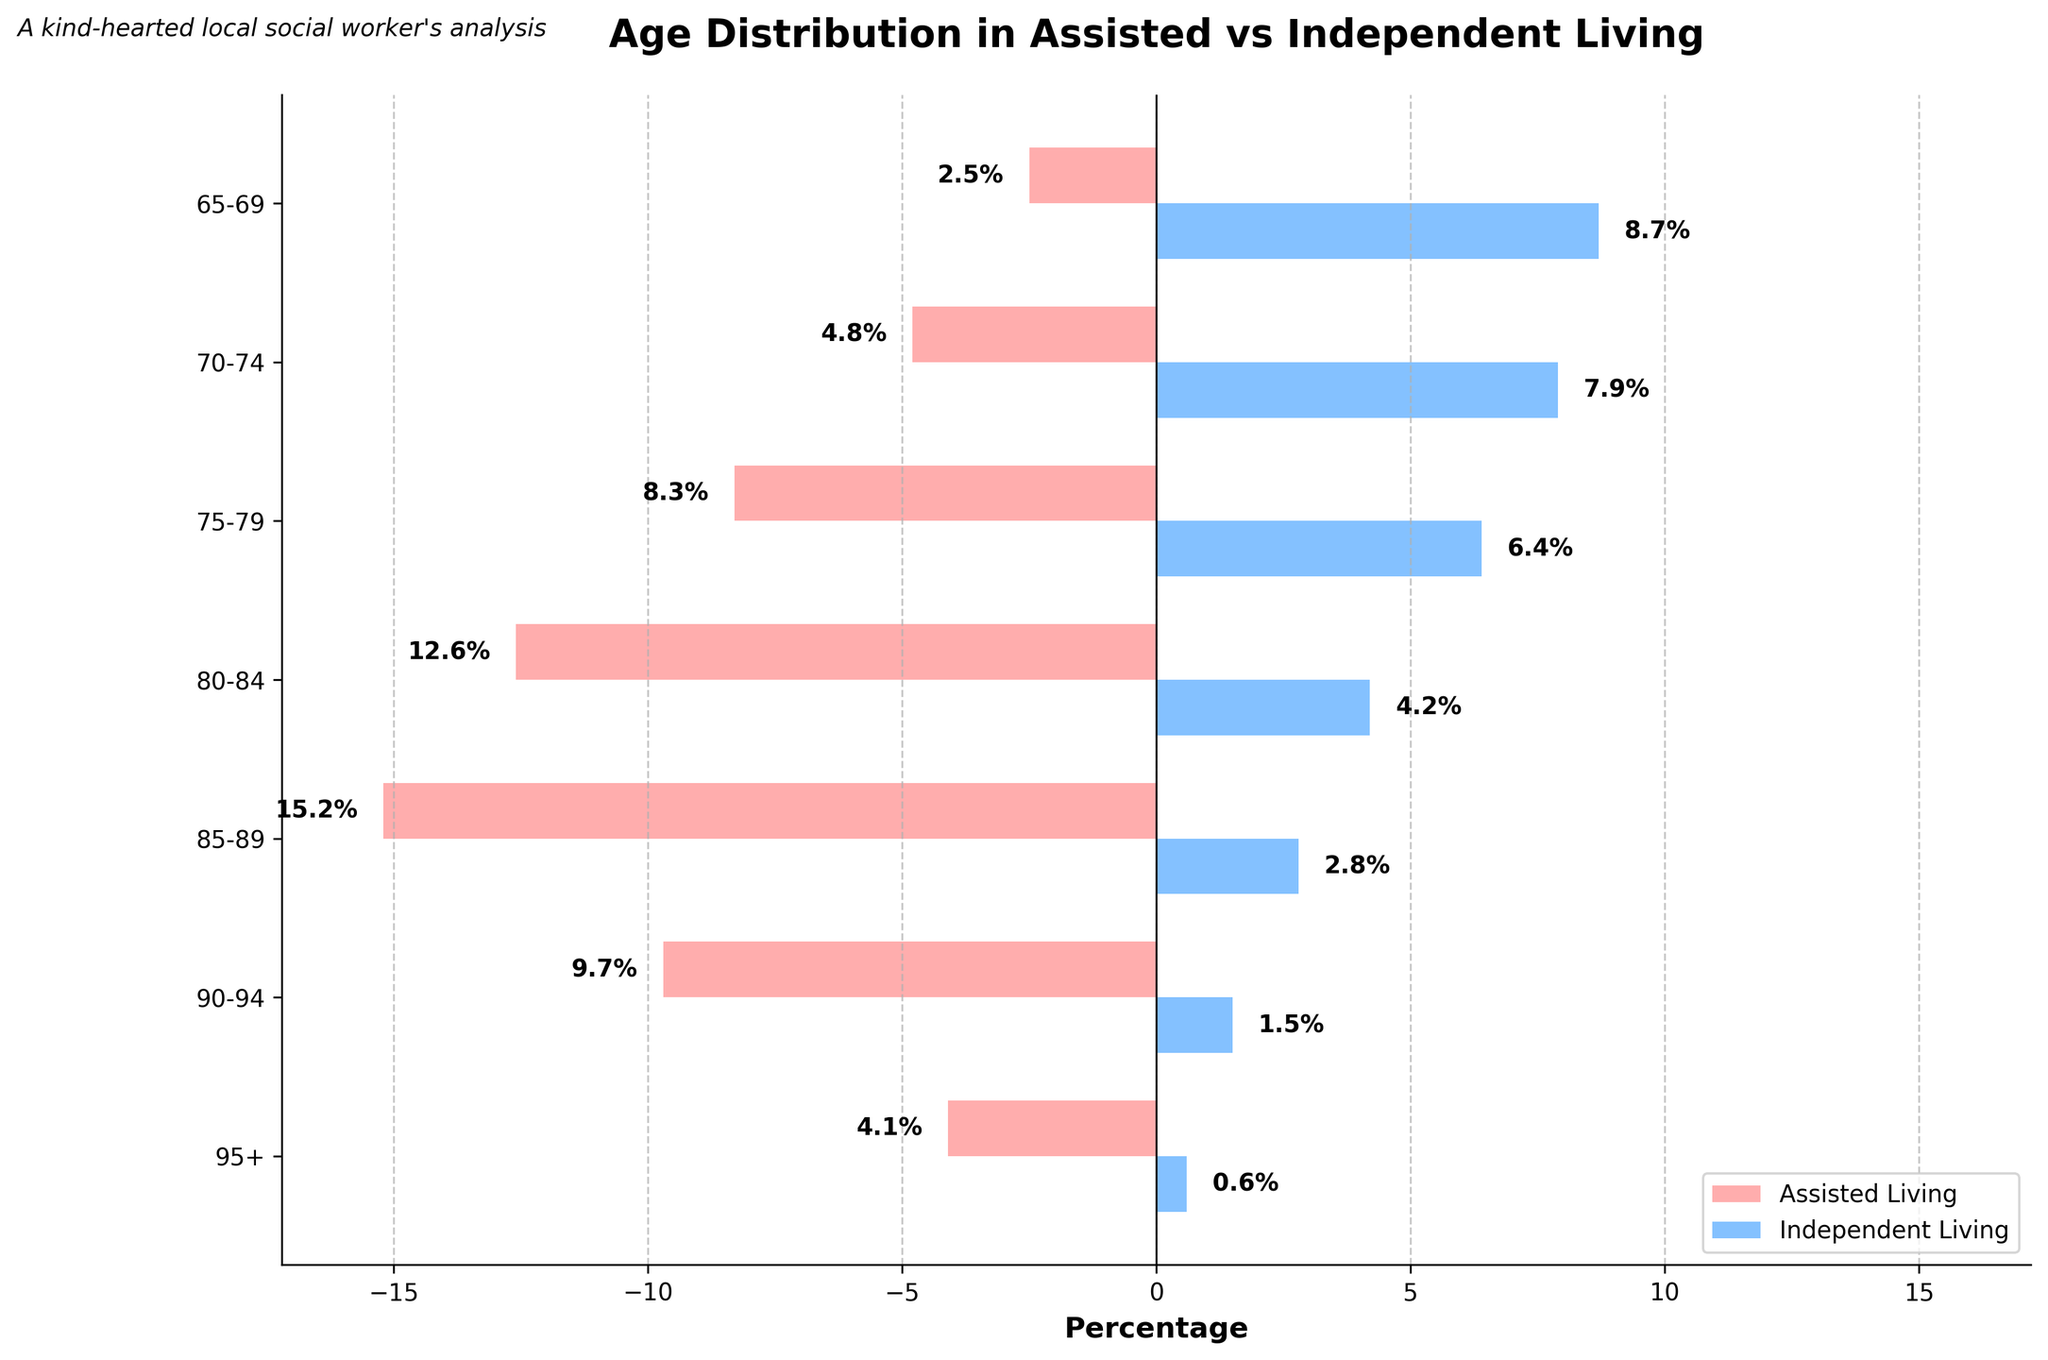What is the title of the figure? The title is usually written prominently at the top of the figure. In this case, it is "Age Distribution in Assisted vs Independent Living".
Answer: Age Distribution in Assisted vs Independent Living What age group has the highest percentage in Assisted Living? By examining the left side of the population pyramid (colored in light red), the highest percentage belongs to the age group "85-89", which has a percentage of 15.2%.
Answer: 85-89 Which age group has the highest percentage in Independent Living? By looking at the right side of the graph (colored in light blue), the age group "65-69" shows the highest percentage, which is 8.7%.
Answer: 65-69 What is the combined percentage of assisted living seniors aged 80-84 and 85-89? First, locate the percentages for "80-84" and "85-89" in the assisted living section: 12.6% and 15.2%, respectively. Adding them gives 12.6 + 15.2 = 27.8%.
Answer: 27.8% How does the percentage of seniors aged 70-74 in Independent Living compare to those in Assisted Living? The percentage for "70-74" in Independent Living is 7.9%, and in Assisted Living, it is 4.8%. Comparing these, 7.9% > 4.8%.
Answer: Independent Living is greater Which age group has the smallest percentage in Independent Living? By reviewing the right side of the pyramid for the smallest value, "95+" stands out with a percentage of 0.6%.
Answer: 95+ What is the age group with the largest difference in percentages between Assisted and Independent Living? Calculate the difference for each age group and compare. For "65-69" (8.7 - 2.5 = 6.2), "70-74" (7.9 - 4.8 = 3.1), "75-79" (6.4 - 8.3 = 1.9), "80-84" (4.2 - 12.6 = 8.4), "85-89" (2.8 - 15.2 = 12.4), "90-94" (1.5 - 9.7 = 8.2), "95+" (0.6 - 4.1 = 3.5), the largest difference is for the "85-89" group with 12.4%.
Answer: 85-89 Which age group has nearly equal percentages in both Assisted and Independent Living? Check for age groups where the percentages are closest. The "70-74" group has percentages of 4.8% in Assisted Living and 7.9% in Independent Living, which are relatively closer but not very close. Observing all, the "75-79" (8.3% vs. 6.4%) is closest but not equal.
Answer: None are nearly equal 